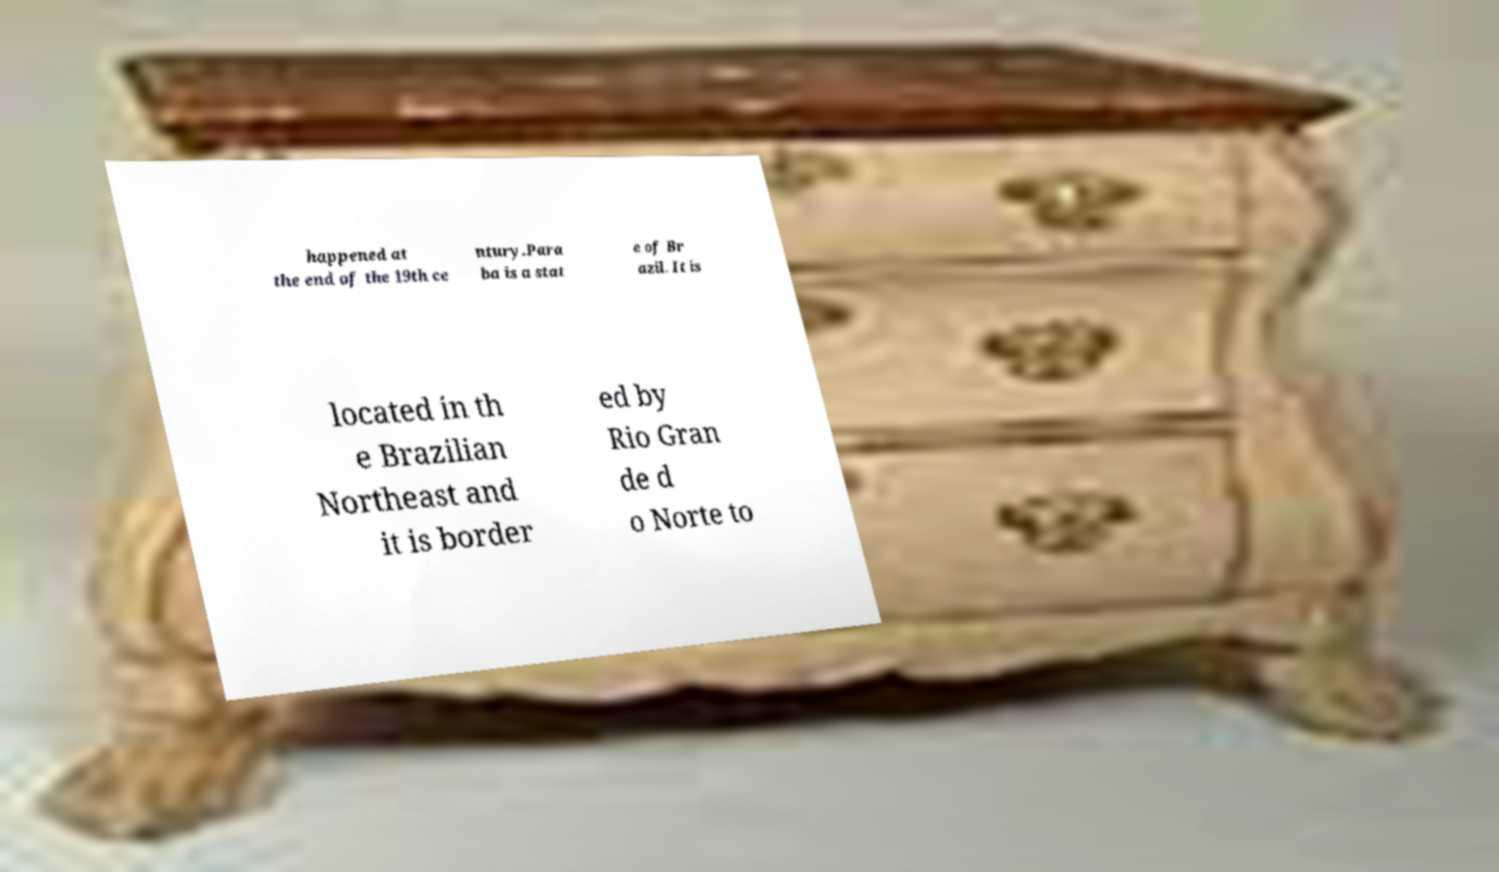I need the written content from this picture converted into text. Can you do that? happened at the end of the 19th ce ntury.Para ba is a stat e of Br azil. It is located in th e Brazilian Northeast and it is border ed by Rio Gran de d o Norte to 